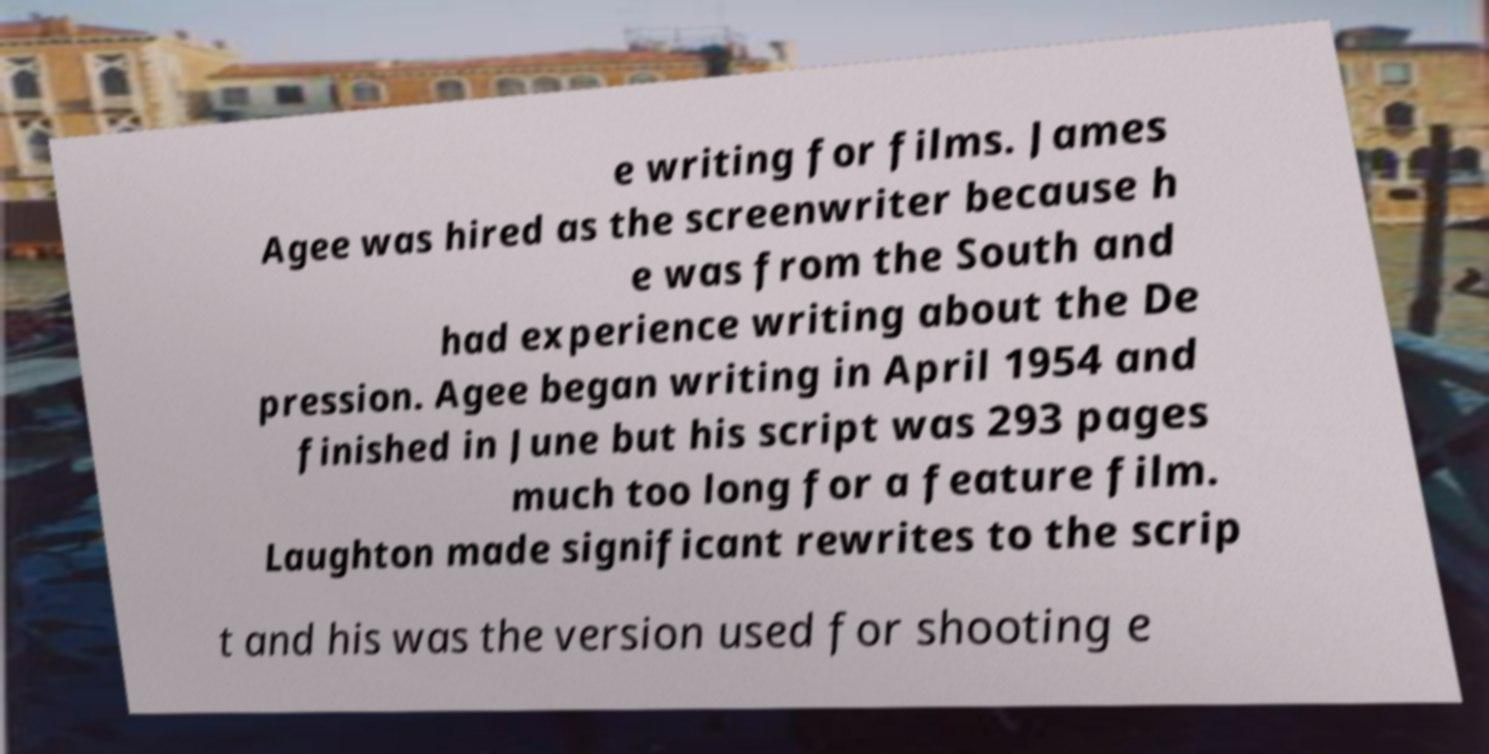For documentation purposes, I need the text within this image transcribed. Could you provide that? e writing for films. James Agee was hired as the screenwriter because h e was from the South and had experience writing about the De pression. Agee began writing in April 1954 and finished in June but his script was 293 pages much too long for a feature film. Laughton made significant rewrites to the scrip t and his was the version used for shooting e 